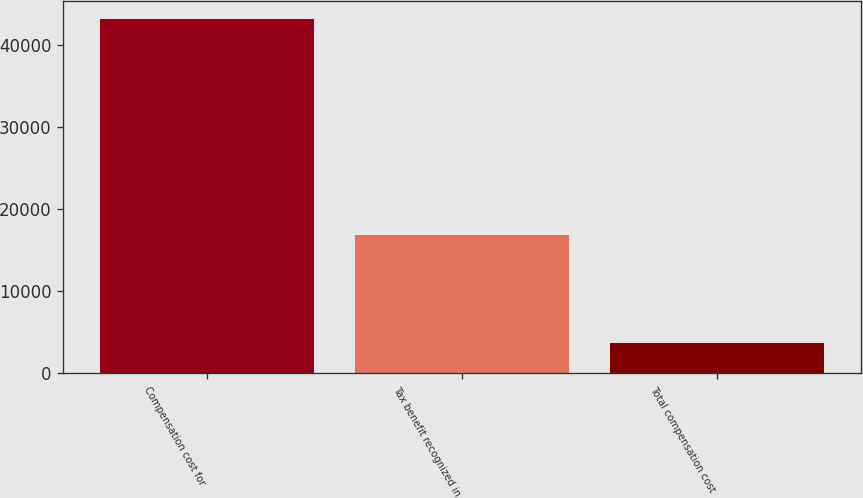<chart> <loc_0><loc_0><loc_500><loc_500><bar_chart><fcel>Compensation cost for<fcel>Tax benefit recognized in<fcel>Total compensation cost<nl><fcel>43253<fcel>16777<fcel>3680<nl></chart> 